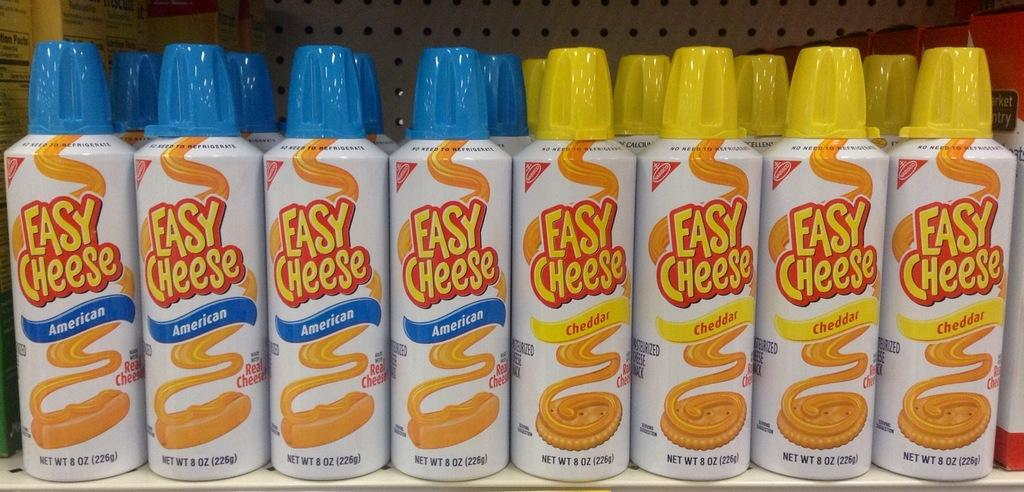<image>
Give a short and clear explanation of the subsequent image. A counter with a selection of Easy Cheese spray 